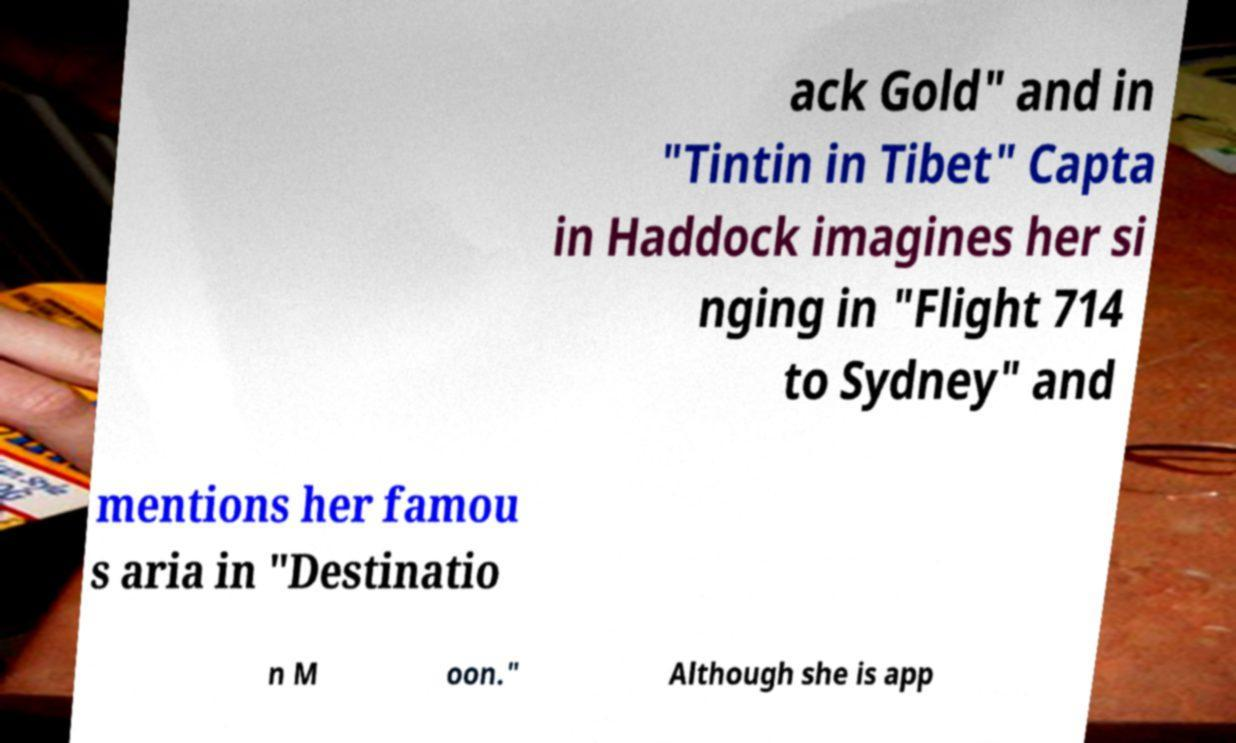Please identify and transcribe the text found in this image. ack Gold" and in "Tintin in Tibet" Capta in Haddock imagines her si nging in "Flight 714 to Sydney" and mentions her famou s aria in "Destinatio n M oon." Although she is app 